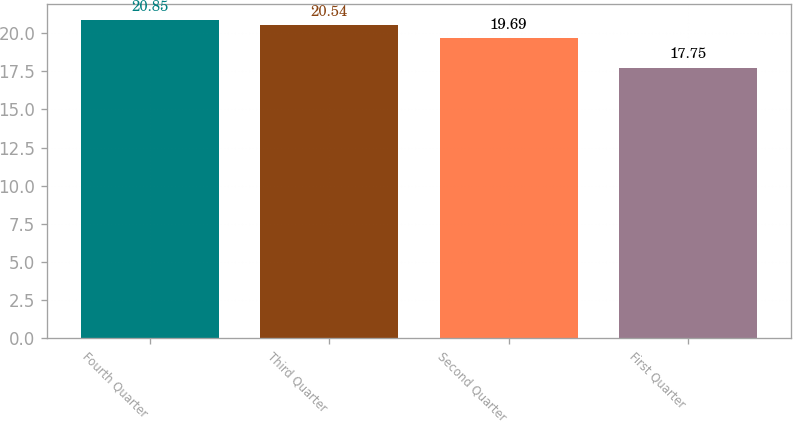<chart> <loc_0><loc_0><loc_500><loc_500><bar_chart><fcel>Fourth Quarter<fcel>Third Quarter<fcel>Second Quarter<fcel>First Quarter<nl><fcel>20.85<fcel>20.54<fcel>19.69<fcel>17.75<nl></chart> 